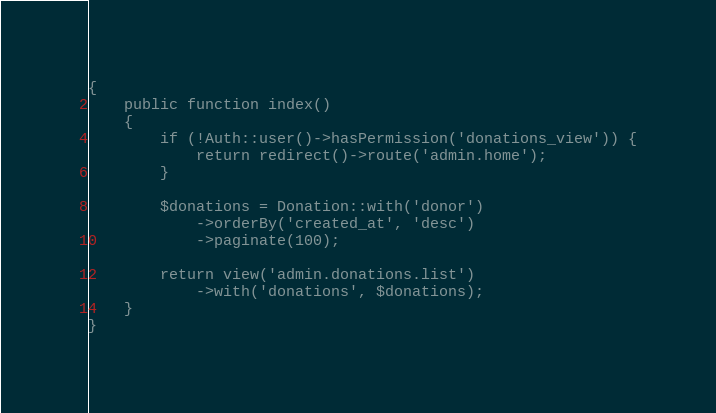Convert code to text. <code><loc_0><loc_0><loc_500><loc_500><_PHP_>{
    public function index()
    {
        if (!Auth::user()->hasPermission('donations_view')) {
            return redirect()->route('admin.home');
        }

        $donations = Donation::with('donor')
            ->orderBy('created_at', 'desc')
            ->paginate(100);

        return view('admin.donations.list')
            ->with('donations', $donations);
    }
}</code> 